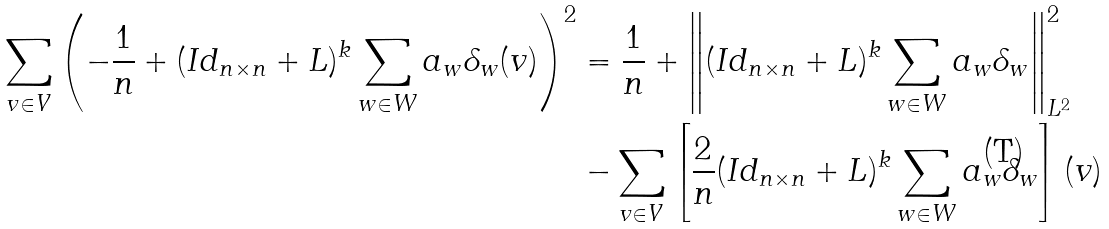Convert formula to latex. <formula><loc_0><loc_0><loc_500><loc_500>\sum _ { v \in V } { \left ( - \frac { 1 } { n } + ( I d _ { n \times n } + L ) ^ { k } \sum _ { w \in W } { a _ { w } \delta _ { w } ( v ) } \right ) ^ { 2 } } & = \frac { 1 } { n } + \left \| ( I d _ { n \times n } + L ) ^ { k } \sum _ { w \in W } { a _ { w } \delta _ { w } } \right \| _ { L ^ { 2 } } ^ { 2 } \\ & - \sum _ { v \in V } { \left [ \frac { 2 } { n } ( I d _ { n \times n } + L ) ^ { k } \sum _ { w \in W } { a _ { w } \delta _ { w } } \right ] ( v ) }</formula> 